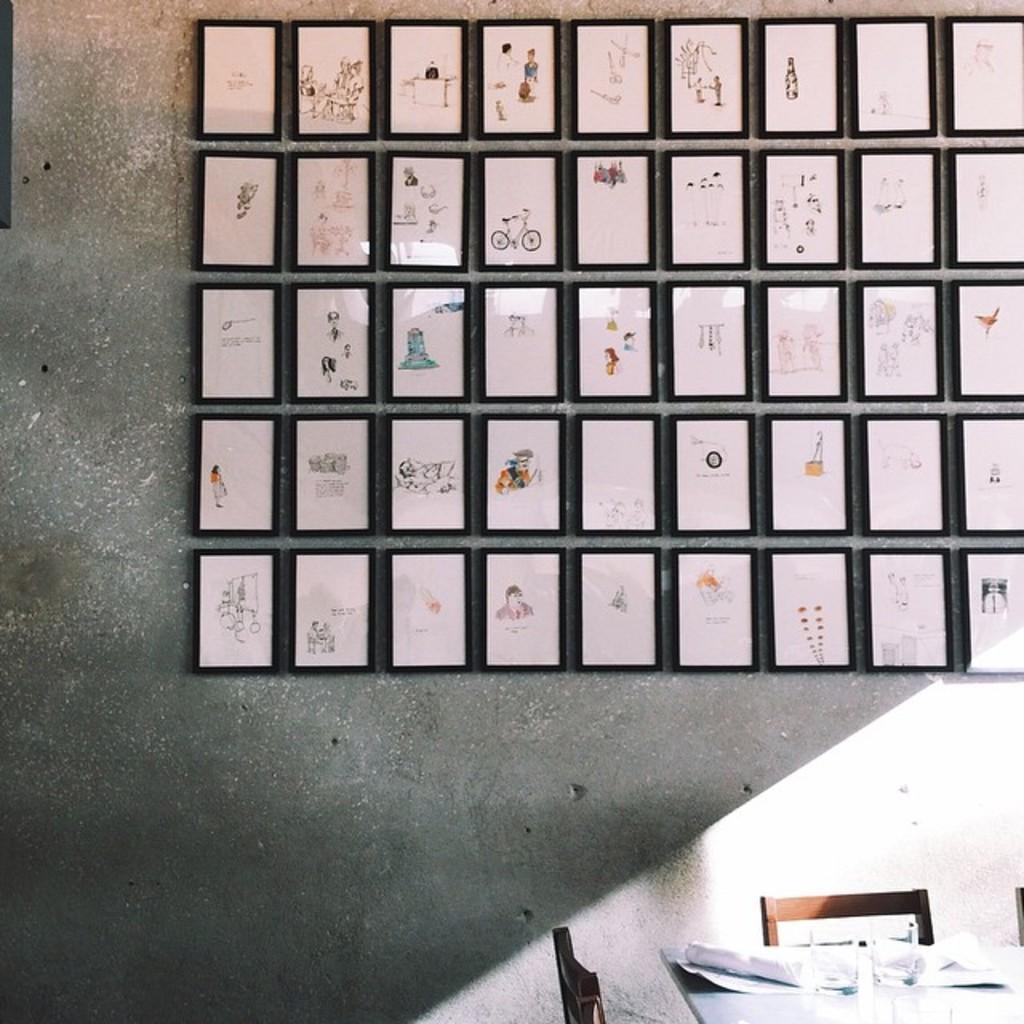Describe this image in one or two sentences. In this image there is a wall, on that wall there are photo frames, in front of the wall there is a table on that table there are papers, around the table there are chairs. 